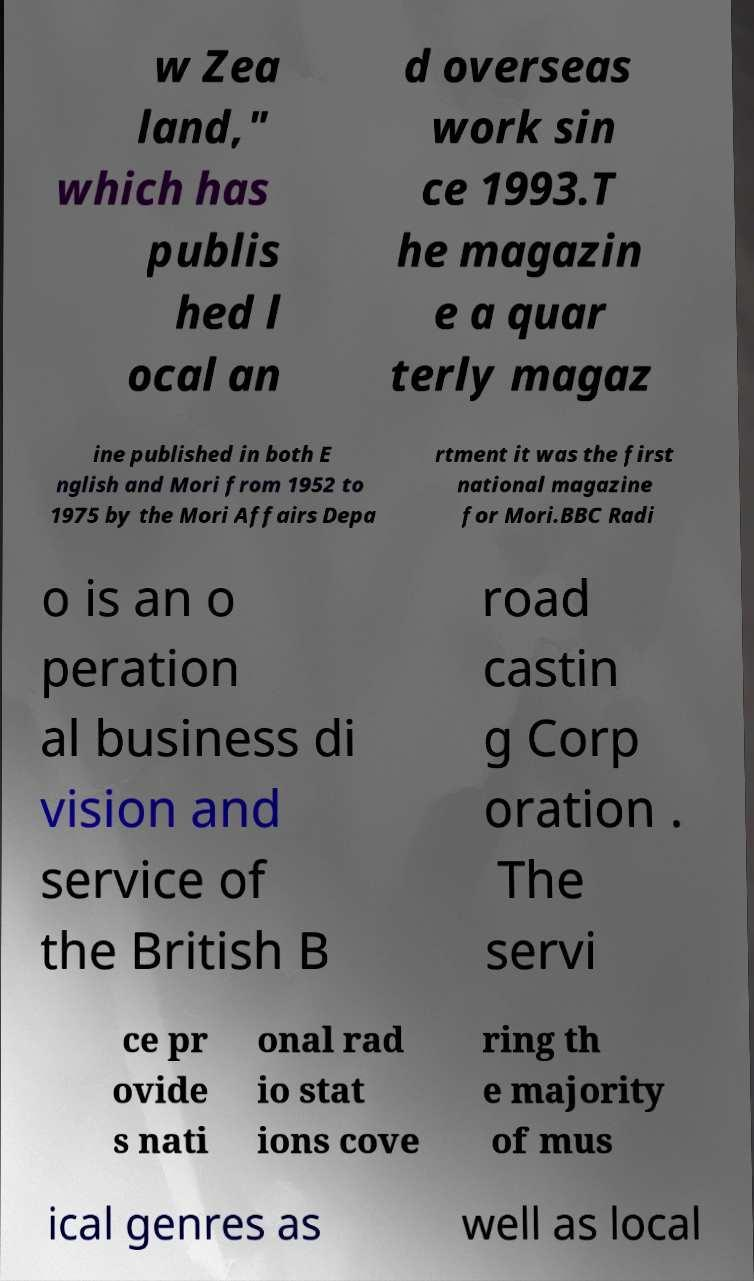There's text embedded in this image that I need extracted. Can you transcribe it verbatim? w Zea land," which has publis hed l ocal an d overseas work sin ce 1993.T he magazin e a quar terly magaz ine published in both E nglish and Mori from 1952 to 1975 by the Mori Affairs Depa rtment it was the first national magazine for Mori.BBC Radi o is an o peration al business di vision and service of the British B road castin g Corp oration . The servi ce pr ovide s nati onal rad io stat ions cove ring th e majority of mus ical genres as well as local 